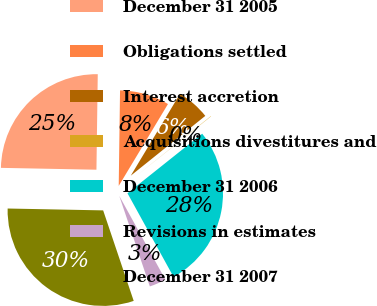<chart> <loc_0><loc_0><loc_500><loc_500><pie_chart><fcel>December 31 2005<fcel>Obligations settled<fcel>Interest accretion<fcel>Acquisitions divestitures and<fcel>December 31 2006<fcel>Revisions in estimates<fcel>December 31 2007<nl><fcel>24.91%<fcel>8.4%<fcel>5.62%<fcel>0.05%<fcel>27.7%<fcel>2.83%<fcel>30.49%<nl></chart> 